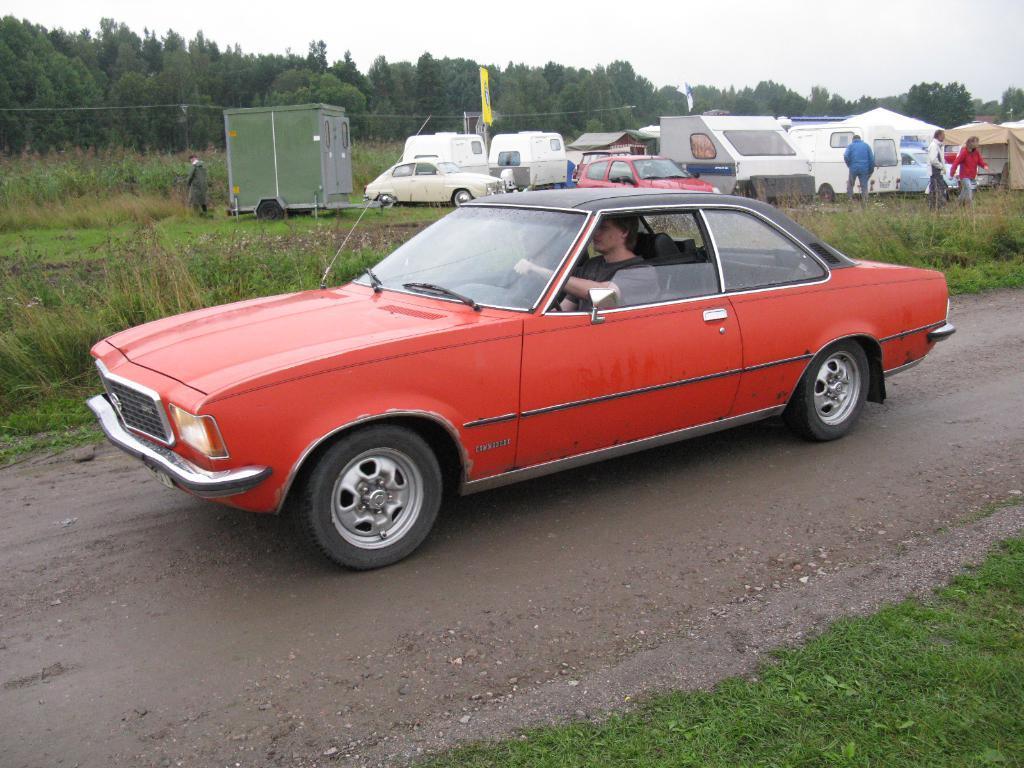Please provide a concise description of this image. This image is taken outdoors. At the top of the image there is the sky with clouds. At the bottom of the image there is a ground with grass on it and there is a road. In the background there are many trees and plants with leaves, stems and branches. There are a few tents and many vehicles are parked on the ground. A few people are walking on the ground. In the middle of the image a car is moving on the road. 